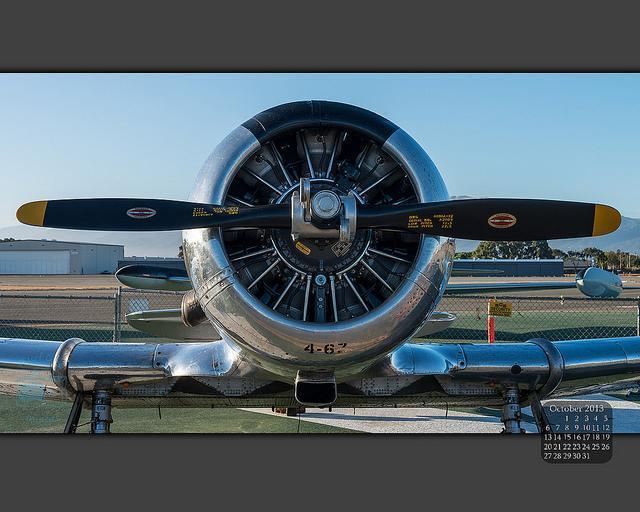How many airplanes can you see?
Give a very brief answer. 1. How many pizzas are on the table?
Give a very brief answer. 0. 